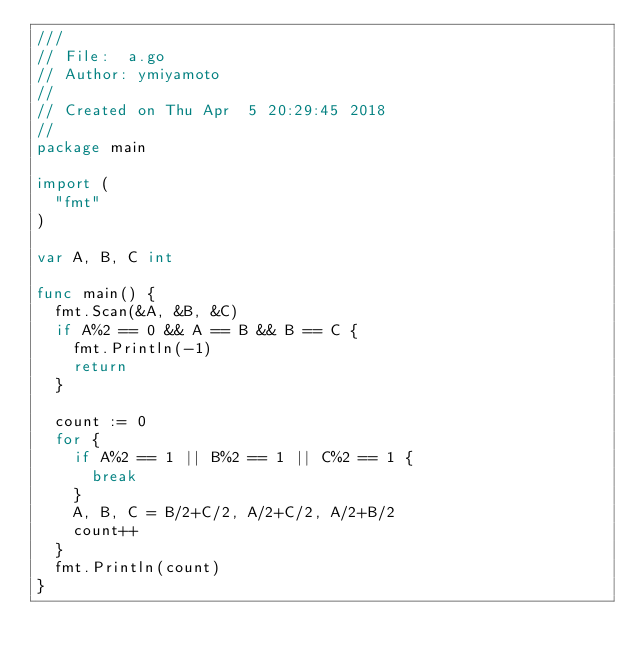<code> <loc_0><loc_0><loc_500><loc_500><_Go_>///
// File:  a.go
// Author: ymiyamoto
//
// Created on Thu Apr  5 20:29:45 2018
//
package main

import (
	"fmt"
)

var A, B, C int

func main() {
	fmt.Scan(&A, &B, &C)
	if A%2 == 0 && A == B && B == C {
		fmt.Println(-1)
		return
	}

	count := 0
	for {
		if A%2 == 1 || B%2 == 1 || C%2 == 1 {
			break
		}
		A, B, C = B/2+C/2, A/2+C/2, A/2+B/2
		count++
	}
	fmt.Println(count)
}
</code> 